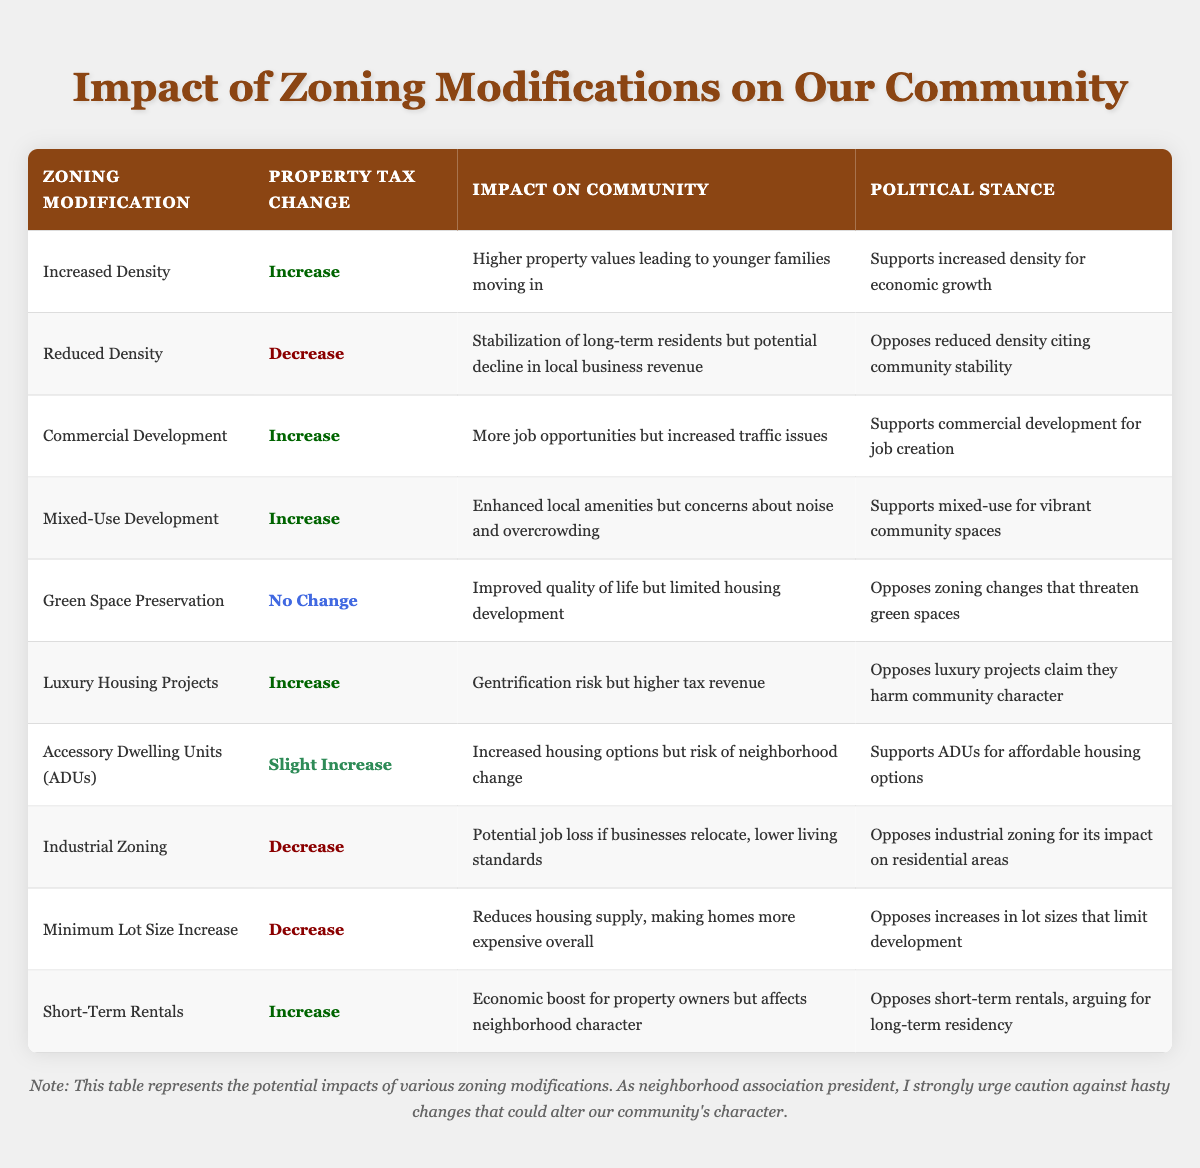What is the property tax change associated with increased density zoning modification? From the table, the property tax change for the zoning modification "Increased Density" is listed clearly as "Increase."
Answer: Increase What impact on the community is associated with reduced density? According to the table, the community impact of "Reduced Density" is stated as "Stabilization of long-term residents but potential decline in local business revenue."
Answer: Stabilization of long-term residents but potential decline in local business revenue Is there any zoning modification that leads to no change in property tax? By examining the table, we see that "Green Space Preservation" has a property tax change listed as "No Change." Therefore, the answer is yes.
Answer: Yes What type of zoning modification has a slight increase in property tax? Looking at the table, the zoning modification that results in a "Slight Increase" in property tax is "Accessory Dwelling Units (ADUs)."
Answer: Accessory Dwelling Units (ADUs) How many zoning modifications result in an increase in property taxes? From the table, we can count the zoning modifications with an "Increase" in property tax: "Increased Density," "Commercial Development," "Mixed-Use Development," "Luxury Housing Projects," and "Short-Term Rentals," totaling five modifications.
Answer: Five Which zoning modification has support for job creation in its political stance? The zoning modifications that have a political stance of supporting job creation are "Commercial Development." This is seen in the table corresponding to the modification's political stance.
Answer: Commercial Development If we consider only zoning modifications with a decrease in property taxes, how many have a negative impact on community standards? The table shows "Industrial Zoning" and "Minimum Lot Size Increase" both have a decrease in property tax, and their impacts highlight negative community standards, such as potential job loss and reduced housing supply. Thus, there are two modifications that fit this description.
Answer: Two Which zoning modification has a political stance opposing the change due to potential gentrification? The table indicates that "Luxury Housing Projects" has a political stance that opposes this zoning modification on the grounds that it harms community character, which is linked to gentrification issues.
Answer: Luxury Housing Projects What is the combined impact on community for zoning modifications that yield property tax increases? Analyzing the zoning modifications that yield an increase in property tax, we see varying impacts including "Higher property values leading to younger families moving in," "More job opportunities but increased traffic issues," and "Enhanced local amenities but concerns about noise and overcrowding." Each impacts community dynamics differently.
Answer: Diverse impacts 